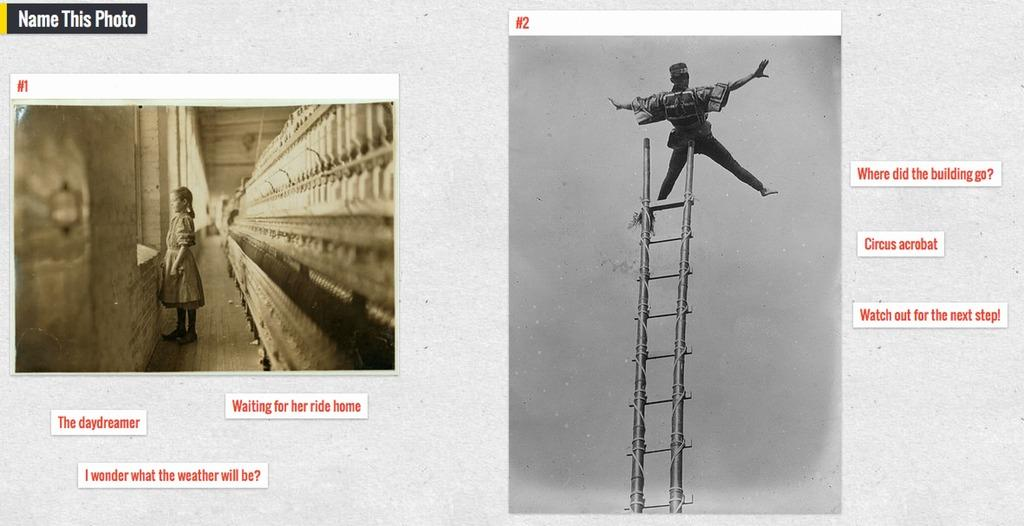<image>
Offer a succinct explanation of the picture presented. Two black and white photos with a title that asks people to name this photo. 